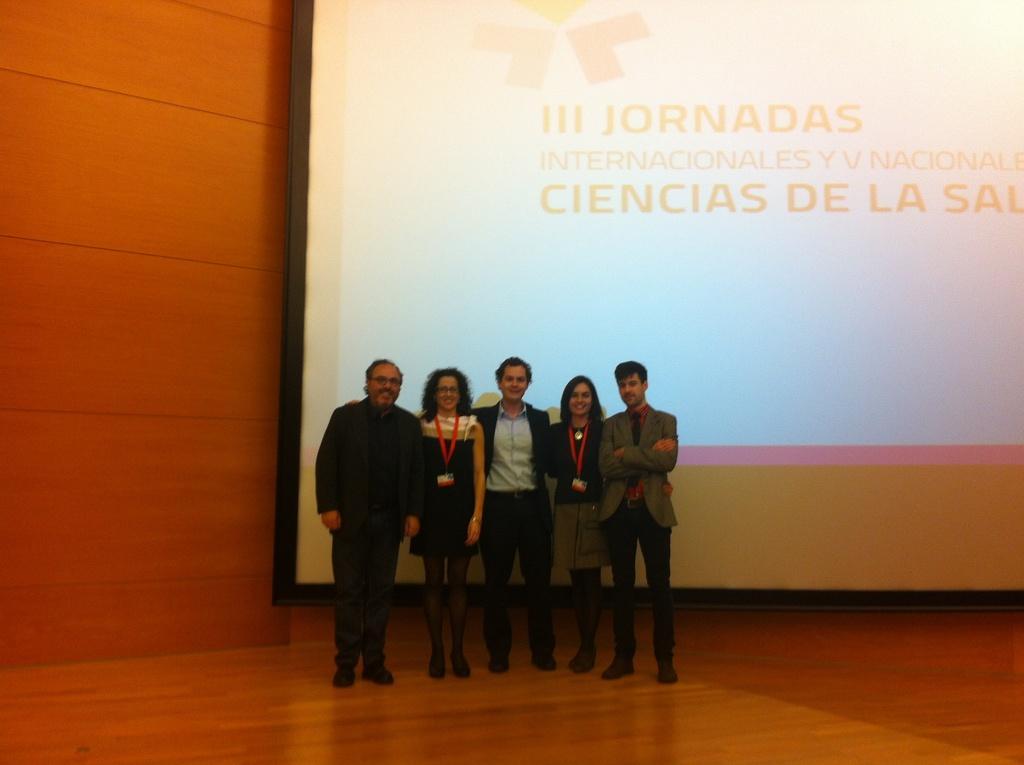Describe this image in one or two sentences. In this image there are three men standing, there are three women standing, the women are wearing an identity card, there is a wooden floor towards the bottom of the image, there is a wall towards the left of the image, there is a screen behind the persons, there is text on the screen. 